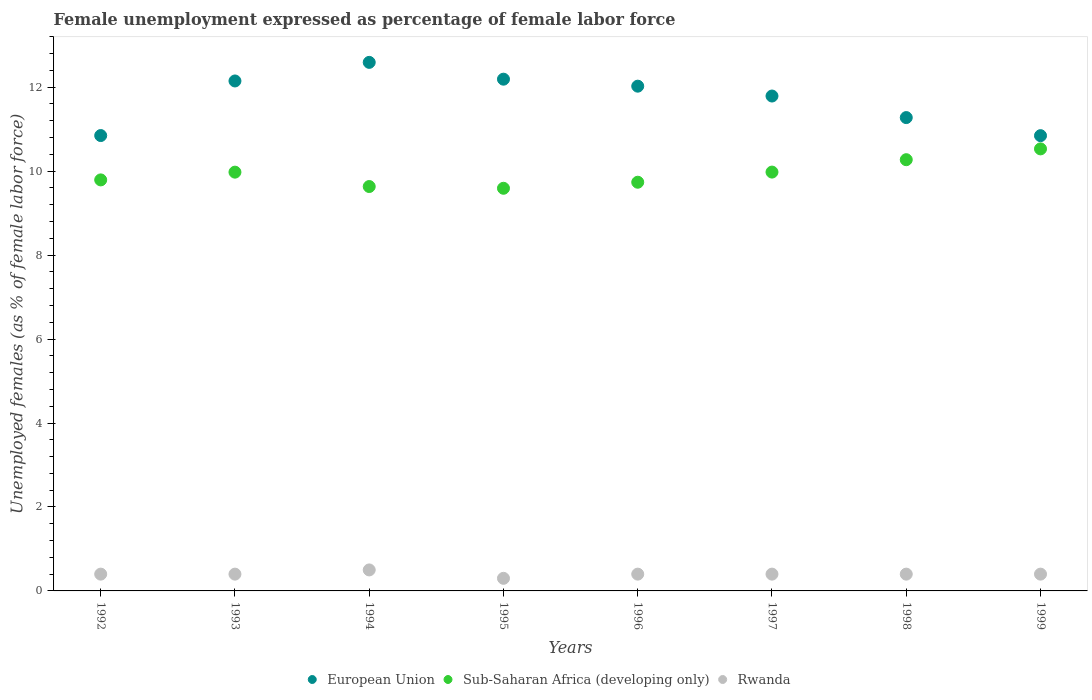What is the unemployment in females in in European Union in 1998?
Offer a terse response. 11.28. Across all years, what is the maximum unemployment in females in in Sub-Saharan Africa (developing only)?
Provide a short and direct response. 10.53. Across all years, what is the minimum unemployment in females in in European Union?
Make the answer very short. 10.84. In which year was the unemployment in females in in Rwanda maximum?
Provide a succinct answer. 1994. What is the total unemployment in females in in European Union in the graph?
Your answer should be compact. 93.71. What is the difference between the unemployment in females in in European Union in 1994 and that in 1995?
Provide a succinct answer. 0.4. What is the difference between the unemployment in females in in Rwanda in 1993 and the unemployment in females in in European Union in 1997?
Provide a succinct answer. -11.39. What is the average unemployment in females in in European Union per year?
Provide a succinct answer. 11.71. In the year 1998, what is the difference between the unemployment in females in in Sub-Saharan Africa (developing only) and unemployment in females in in European Union?
Offer a very short reply. -1. What is the ratio of the unemployment in females in in Rwanda in 1995 to that in 1998?
Ensure brevity in your answer.  0.75. Is the unemployment in females in in European Union in 1992 less than that in 1993?
Offer a terse response. Yes. What is the difference between the highest and the second highest unemployment in females in in Rwanda?
Make the answer very short. 0.1. What is the difference between the highest and the lowest unemployment in females in in Sub-Saharan Africa (developing only)?
Ensure brevity in your answer.  0.94. In how many years, is the unemployment in females in in European Union greater than the average unemployment in females in in European Union taken over all years?
Your response must be concise. 5. Is the sum of the unemployment in females in in European Union in 1992 and 1995 greater than the maximum unemployment in females in in Sub-Saharan Africa (developing only) across all years?
Ensure brevity in your answer.  Yes. Is it the case that in every year, the sum of the unemployment in females in in Rwanda and unemployment in females in in European Union  is greater than the unemployment in females in in Sub-Saharan Africa (developing only)?
Make the answer very short. Yes. Does the unemployment in females in in Rwanda monotonically increase over the years?
Make the answer very short. No. Is the unemployment in females in in Sub-Saharan Africa (developing only) strictly greater than the unemployment in females in in European Union over the years?
Offer a very short reply. No. Is the unemployment in females in in Sub-Saharan Africa (developing only) strictly less than the unemployment in females in in European Union over the years?
Ensure brevity in your answer.  Yes. Are the values on the major ticks of Y-axis written in scientific E-notation?
Offer a very short reply. No. Does the graph contain any zero values?
Your answer should be compact. No. How many legend labels are there?
Offer a terse response. 3. What is the title of the graph?
Offer a terse response. Female unemployment expressed as percentage of female labor force. Does "Sao Tome and Principe" appear as one of the legend labels in the graph?
Ensure brevity in your answer.  No. What is the label or title of the X-axis?
Provide a short and direct response. Years. What is the label or title of the Y-axis?
Your response must be concise. Unemployed females (as % of female labor force). What is the Unemployed females (as % of female labor force) in European Union in 1992?
Keep it short and to the point. 10.85. What is the Unemployed females (as % of female labor force) in Sub-Saharan Africa (developing only) in 1992?
Provide a short and direct response. 9.79. What is the Unemployed females (as % of female labor force) in Rwanda in 1992?
Offer a very short reply. 0.4. What is the Unemployed females (as % of female labor force) in European Union in 1993?
Provide a succinct answer. 12.15. What is the Unemployed females (as % of female labor force) of Sub-Saharan Africa (developing only) in 1993?
Ensure brevity in your answer.  9.98. What is the Unemployed females (as % of female labor force) of Rwanda in 1993?
Make the answer very short. 0.4. What is the Unemployed females (as % of female labor force) of European Union in 1994?
Your response must be concise. 12.59. What is the Unemployed females (as % of female labor force) in Sub-Saharan Africa (developing only) in 1994?
Offer a terse response. 9.63. What is the Unemployed females (as % of female labor force) of European Union in 1995?
Keep it short and to the point. 12.19. What is the Unemployed females (as % of female labor force) of Sub-Saharan Africa (developing only) in 1995?
Keep it short and to the point. 9.59. What is the Unemployed females (as % of female labor force) in Rwanda in 1995?
Ensure brevity in your answer.  0.3. What is the Unemployed females (as % of female labor force) of European Union in 1996?
Your answer should be very brief. 12.02. What is the Unemployed females (as % of female labor force) in Sub-Saharan Africa (developing only) in 1996?
Your response must be concise. 9.74. What is the Unemployed females (as % of female labor force) of Rwanda in 1996?
Make the answer very short. 0.4. What is the Unemployed females (as % of female labor force) of European Union in 1997?
Your answer should be very brief. 11.79. What is the Unemployed females (as % of female labor force) in Sub-Saharan Africa (developing only) in 1997?
Ensure brevity in your answer.  9.98. What is the Unemployed females (as % of female labor force) in Rwanda in 1997?
Make the answer very short. 0.4. What is the Unemployed females (as % of female labor force) in European Union in 1998?
Make the answer very short. 11.28. What is the Unemployed females (as % of female labor force) in Sub-Saharan Africa (developing only) in 1998?
Your response must be concise. 10.27. What is the Unemployed females (as % of female labor force) in Rwanda in 1998?
Your answer should be compact. 0.4. What is the Unemployed females (as % of female labor force) in European Union in 1999?
Offer a very short reply. 10.84. What is the Unemployed females (as % of female labor force) in Sub-Saharan Africa (developing only) in 1999?
Your answer should be compact. 10.53. What is the Unemployed females (as % of female labor force) of Rwanda in 1999?
Make the answer very short. 0.4. Across all years, what is the maximum Unemployed females (as % of female labor force) in European Union?
Keep it short and to the point. 12.59. Across all years, what is the maximum Unemployed females (as % of female labor force) in Sub-Saharan Africa (developing only)?
Your answer should be very brief. 10.53. Across all years, what is the minimum Unemployed females (as % of female labor force) of European Union?
Provide a succinct answer. 10.84. Across all years, what is the minimum Unemployed females (as % of female labor force) of Sub-Saharan Africa (developing only)?
Your response must be concise. 9.59. Across all years, what is the minimum Unemployed females (as % of female labor force) in Rwanda?
Offer a very short reply. 0.3. What is the total Unemployed females (as % of female labor force) of European Union in the graph?
Provide a short and direct response. 93.71. What is the total Unemployed females (as % of female labor force) in Sub-Saharan Africa (developing only) in the graph?
Keep it short and to the point. 79.51. What is the difference between the Unemployed females (as % of female labor force) in European Union in 1992 and that in 1993?
Provide a short and direct response. -1.3. What is the difference between the Unemployed females (as % of female labor force) of Sub-Saharan Africa (developing only) in 1992 and that in 1993?
Your answer should be compact. -0.18. What is the difference between the Unemployed females (as % of female labor force) in European Union in 1992 and that in 1994?
Your answer should be very brief. -1.74. What is the difference between the Unemployed females (as % of female labor force) in Sub-Saharan Africa (developing only) in 1992 and that in 1994?
Offer a terse response. 0.16. What is the difference between the Unemployed females (as % of female labor force) of Rwanda in 1992 and that in 1994?
Offer a terse response. -0.1. What is the difference between the Unemployed females (as % of female labor force) in European Union in 1992 and that in 1995?
Give a very brief answer. -1.34. What is the difference between the Unemployed females (as % of female labor force) of Sub-Saharan Africa (developing only) in 1992 and that in 1995?
Your answer should be very brief. 0.2. What is the difference between the Unemployed females (as % of female labor force) in European Union in 1992 and that in 1996?
Give a very brief answer. -1.18. What is the difference between the Unemployed females (as % of female labor force) in Sub-Saharan Africa (developing only) in 1992 and that in 1996?
Offer a very short reply. 0.06. What is the difference between the Unemployed females (as % of female labor force) of European Union in 1992 and that in 1997?
Keep it short and to the point. -0.94. What is the difference between the Unemployed females (as % of female labor force) of Sub-Saharan Africa (developing only) in 1992 and that in 1997?
Make the answer very short. -0.19. What is the difference between the Unemployed females (as % of female labor force) in European Union in 1992 and that in 1998?
Provide a succinct answer. -0.43. What is the difference between the Unemployed females (as % of female labor force) of Sub-Saharan Africa (developing only) in 1992 and that in 1998?
Ensure brevity in your answer.  -0.48. What is the difference between the Unemployed females (as % of female labor force) of European Union in 1992 and that in 1999?
Make the answer very short. 0. What is the difference between the Unemployed females (as % of female labor force) in Sub-Saharan Africa (developing only) in 1992 and that in 1999?
Offer a terse response. -0.74. What is the difference between the Unemployed females (as % of female labor force) in European Union in 1993 and that in 1994?
Provide a short and direct response. -0.44. What is the difference between the Unemployed females (as % of female labor force) of Sub-Saharan Africa (developing only) in 1993 and that in 1994?
Make the answer very short. 0.34. What is the difference between the Unemployed females (as % of female labor force) of European Union in 1993 and that in 1995?
Offer a terse response. -0.04. What is the difference between the Unemployed females (as % of female labor force) in Sub-Saharan Africa (developing only) in 1993 and that in 1995?
Offer a very short reply. 0.38. What is the difference between the Unemployed females (as % of female labor force) of Rwanda in 1993 and that in 1995?
Your response must be concise. 0.1. What is the difference between the Unemployed females (as % of female labor force) in European Union in 1993 and that in 1996?
Your answer should be compact. 0.12. What is the difference between the Unemployed females (as % of female labor force) of Sub-Saharan Africa (developing only) in 1993 and that in 1996?
Make the answer very short. 0.24. What is the difference between the Unemployed females (as % of female labor force) of European Union in 1993 and that in 1997?
Your answer should be very brief. 0.36. What is the difference between the Unemployed females (as % of female labor force) of Sub-Saharan Africa (developing only) in 1993 and that in 1997?
Give a very brief answer. -0. What is the difference between the Unemployed females (as % of female labor force) in Rwanda in 1993 and that in 1997?
Your response must be concise. 0. What is the difference between the Unemployed females (as % of female labor force) in European Union in 1993 and that in 1998?
Provide a succinct answer. 0.87. What is the difference between the Unemployed females (as % of female labor force) in Sub-Saharan Africa (developing only) in 1993 and that in 1998?
Provide a succinct answer. -0.3. What is the difference between the Unemployed females (as % of female labor force) in European Union in 1993 and that in 1999?
Provide a short and direct response. 1.3. What is the difference between the Unemployed females (as % of female labor force) in Sub-Saharan Africa (developing only) in 1993 and that in 1999?
Your response must be concise. -0.55. What is the difference between the Unemployed females (as % of female labor force) of European Union in 1994 and that in 1995?
Your answer should be very brief. 0.4. What is the difference between the Unemployed females (as % of female labor force) in Sub-Saharan Africa (developing only) in 1994 and that in 1995?
Keep it short and to the point. 0.04. What is the difference between the Unemployed females (as % of female labor force) of European Union in 1994 and that in 1996?
Your answer should be compact. 0.57. What is the difference between the Unemployed females (as % of female labor force) of Sub-Saharan Africa (developing only) in 1994 and that in 1996?
Offer a terse response. -0.1. What is the difference between the Unemployed females (as % of female labor force) in European Union in 1994 and that in 1997?
Make the answer very short. 0.8. What is the difference between the Unemployed females (as % of female labor force) of Sub-Saharan Africa (developing only) in 1994 and that in 1997?
Offer a very short reply. -0.34. What is the difference between the Unemployed females (as % of female labor force) in Rwanda in 1994 and that in 1997?
Provide a short and direct response. 0.1. What is the difference between the Unemployed females (as % of female labor force) of European Union in 1994 and that in 1998?
Offer a very short reply. 1.32. What is the difference between the Unemployed females (as % of female labor force) of Sub-Saharan Africa (developing only) in 1994 and that in 1998?
Keep it short and to the point. -0.64. What is the difference between the Unemployed females (as % of female labor force) in European Union in 1994 and that in 1999?
Offer a very short reply. 1.75. What is the difference between the Unemployed females (as % of female labor force) in Sub-Saharan Africa (developing only) in 1994 and that in 1999?
Your response must be concise. -0.9. What is the difference between the Unemployed females (as % of female labor force) of European Union in 1995 and that in 1996?
Your answer should be compact. 0.17. What is the difference between the Unemployed females (as % of female labor force) of Sub-Saharan Africa (developing only) in 1995 and that in 1996?
Keep it short and to the point. -0.14. What is the difference between the Unemployed females (as % of female labor force) in European Union in 1995 and that in 1997?
Your answer should be very brief. 0.4. What is the difference between the Unemployed females (as % of female labor force) in Sub-Saharan Africa (developing only) in 1995 and that in 1997?
Your response must be concise. -0.39. What is the difference between the Unemployed females (as % of female labor force) in European Union in 1995 and that in 1998?
Your answer should be very brief. 0.91. What is the difference between the Unemployed females (as % of female labor force) in Sub-Saharan Africa (developing only) in 1995 and that in 1998?
Keep it short and to the point. -0.68. What is the difference between the Unemployed females (as % of female labor force) of Rwanda in 1995 and that in 1998?
Offer a terse response. -0.1. What is the difference between the Unemployed females (as % of female labor force) in European Union in 1995 and that in 1999?
Offer a very short reply. 1.35. What is the difference between the Unemployed females (as % of female labor force) in Sub-Saharan Africa (developing only) in 1995 and that in 1999?
Ensure brevity in your answer.  -0.94. What is the difference between the Unemployed females (as % of female labor force) of Rwanda in 1995 and that in 1999?
Keep it short and to the point. -0.1. What is the difference between the Unemployed females (as % of female labor force) of European Union in 1996 and that in 1997?
Your response must be concise. 0.23. What is the difference between the Unemployed females (as % of female labor force) of Sub-Saharan Africa (developing only) in 1996 and that in 1997?
Ensure brevity in your answer.  -0.24. What is the difference between the Unemployed females (as % of female labor force) in Rwanda in 1996 and that in 1997?
Provide a succinct answer. 0. What is the difference between the Unemployed females (as % of female labor force) of European Union in 1996 and that in 1998?
Offer a terse response. 0.75. What is the difference between the Unemployed females (as % of female labor force) of Sub-Saharan Africa (developing only) in 1996 and that in 1998?
Make the answer very short. -0.54. What is the difference between the Unemployed females (as % of female labor force) of Rwanda in 1996 and that in 1998?
Your answer should be very brief. 0. What is the difference between the Unemployed females (as % of female labor force) of European Union in 1996 and that in 1999?
Offer a very short reply. 1.18. What is the difference between the Unemployed females (as % of female labor force) of Sub-Saharan Africa (developing only) in 1996 and that in 1999?
Offer a terse response. -0.79. What is the difference between the Unemployed females (as % of female labor force) in European Union in 1997 and that in 1998?
Give a very brief answer. 0.51. What is the difference between the Unemployed females (as % of female labor force) of Sub-Saharan Africa (developing only) in 1997 and that in 1998?
Keep it short and to the point. -0.3. What is the difference between the Unemployed females (as % of female labor force) in Rwanda in 1997 and that in 1998?
Keep it short and to the point. 0. What is the difference between the Unemployed females (as % of female labor force) in European Union in 1997 and that in 1999?
Offer a terse response. 0.94. What is the difference between the Unemployed females (as % of female labor force) in Sub-Saharan Africa (developing only) in 1997 and that in 1999?
Keep it short and to the point. -0.55. What is the difference between the Unemployed females (as % of female labor force) in Rwanda in 1997 and that in 1999?
Offer a terse response. 0. What is the difference between the Unemployed females (as % of female labor force) in European Union in 1998 and that in 1999?
Give a very brief answer. 0.43. What is the difference between the Unemployed females (as % of female labor force) of Sub-Saharan Africa (developing only) in 1998 and that in 1999?
Offer a terse response. -0.26. What is the difference between the Unemployed females (as % of female labor force) in Rwanda in 1998 and that in 1999?
Provide a succinct answer. 0. What is the difference between the Unemployed females (as % of female labor force) of European Union in 1992 and the Unemployed females (as % of female labor force) of Sub-Saharan Africa (developing only) in 1993?
Offer a terse response. 0.87. What is the difference between the Unemployed females (as % of female labor force) in European Union in 1992 and the Unemployed females (as % of female labor force) in Rwanda in 1993?
Your response must be concise. 10.45. What is the difference between the Unemployed females (as % of female labor force) in Sub-Saharan Africa (developing only) in 1992 and the Unemployed females (as % of female labor force) in Rwanda in 1993?
Keep it short and to the point. 9.39. What is the difference between the Unemployed females (as % of female labor force) of European Union in 1992 and the Unemployed females (as % of female labor force) of Sub-Saharan Africa (developing only) in 1994?
Provide a succinct answer. 1.21. What is the difference between the Unemployed females (as % of female labor force) of European Union in 1992 and the Unemployed females (as % of female labor force) of Rwanda in 1994?
Your response must be concise. 10.35. What is the difference between the Unemployed females (as % of female labor force) of Sub-Saharan Africa (developing only) in 1992 and the Unemployed females (as % of female labor force) of Rwanda in 1994?
Offer a terse response. 9.29. What is the difference between the Unemployed females (as % of female labor force) in European Union in 1992 and the Unemployed females (as % of female labor force) in Sub-Saharan Africa (developing only) in 1995?
Offer a very short reply. 1.26. What is the difference between the Unemployed females (as % of female labor force) in European Union in 1992 and the Unemployed females (as % of female labor force) in Rwanda in 1995?
Your response must be concise. 10.55. What is the difference between the Unemployed females (as % of female labor force) in Sub-Saharan Africa (developing only) in 1992 and the Unemployed females (as % of female labor force) in Rwanda in 1995?
Provide a short and direct response. 9.49. What is the difference between the Unemployed females (as % of female labor force) of European Union in 1992 and the Unemployed females (as % of female labor force) of Sub-Saharan Africa (developing only) in 1996?
Your answer should be compact. 1.11. What is the difference between the Unemployed females (as % of female labor force) of European Union in 1992 and the Unemployed females (as % of female labor force) of Rwanda in 1996?
Give a very brief answer. 10.45. What is the difference between the Unemployed females (as % of female labor force) in Sub-Saharan Africa (developing only) in 1992 and the Unemployed females (as % of female labor force) in Rwanda in 1996?
Your response must be concise. 9.39. What is the difference between the Unemployed females (as % of female labor force) in European Union in 1992 and the Unemployed females (as % of female labor force) in Sub-Saharan Africa (developing only) in 1997?
Provide a short and direct response. 0.87. What is the difference between the Unemployed females (as % of female labor force) in European Union in 1992 and the Unemployed females (as % of female labor force) in Rwanda in 1997?
Make the answer very short. 10.45. What is the difference between the Unemployed females (as % of female labor force) in Sub-Saharan Africa (developing only) in 1992 and the Unemployed females (as % of female labor force) in Rwanda in 1997?
Offer a very short reply. 9.39. What is the difference between the Unemployed females (as % of female labor force) of European Union in 1992 and the Unemployed females (as % of female labor force) of Sub-Saharan Africa (developing only) in 1998?
Keep it short and to the point. 0.57. What is the difference between the Unemployed females (as % of female labor force) in European Union in 1992 and the Unemployed females (as % of female labor force) in Rwanda in 1998?
Your response must be concise. 10.45. What is the difference between the Unemployed females (as % of female labor force) of Sub-Saharan Africa (developing only) in 1992 and the Unemployed females (as % of female labor force) of Rwanda in 1998?
Keep it short and to the point. 9.39. What is the difference between the Unemployed females (as % of female labor force) of European Union in 1992 and the Unemployed females (as % of female labor force) of Sub-Saharan Africa (developing only) in 1999?
Keep it short and to the point. 0.32. What is the difference between the Unemployed females (as % of female labor force) of European Union in 1992 and the Unemployed females (as % of female labor force) of Rwanda in 1999?
Offer a very short reply. 10.45. What is the difference between the Unemployed females (as % of female labor force) of Sub-Saharan Africa (developing only) in 1992 and the Unemployed females (as % of female labor force) of Rwanda in 1999?
Offer a terse response. 9.39. What is the difference between the Unemployed females (as % of female labor force) in European Union in 1993 and the Unemployed females (as % of female labor force) in Sub-Saharan Africa (developing only) in 1994?
Your answer should be very brief. 2.51. What is the difference between the Unemployed females (as % of female labor force) of European Union in 1993 and the Unemployed females (as % of female labor force) of Rwanda in 1994?
Your response must be concise. 11.65. What is the difference between the Unemployed females (as % of female labor force) in Sub-Saharan Africa (developing only) in 1993 and the Unemployed females (as % of female labor force) in Rwanda in 1994?
Ensure brevity in your answer.  9.48. What is the difference between the Unemployed females (as % of female labor force) of European Union in 1993 and the Unemployed females (as % of female labor force) of Sub-Saharan Africa (developing only) in 1995?
Your response must be concise. 2.56. What is the difference between the Unemployed females (as % of female labor force) in European Union in 1993 and the Unemployed females (as % of female labor force) in Rwanda in 1995?
Ensure brevity in your answer.  11.85. What is the difference between the Unemployed females (as % of female labor force) in Sub-Saharan Africa (developing only) in 1993 and the Unemployed females (as % of female labor force) in Rwanda in 1995?
Ensure brevity in your answer.  9.68. What is the difference between the Unemployed females (as % of female labor force) of European Union in 1993 and the Unemployed females (as % of female labor force) of Sub-Saharan Africa (developing only) in 1996?
Provide a short and direct response. 2.41. What is the difference between the Unemployed females (as % of female labor force) in European Union in 1993 and the Unemployed females (as % of female labor force) in Rwanda in 1996?
Give a very brief answer. 11.75. What is the difference between the Unemployed females (as % of female labor force) in Sub-Saharan Africa (developing only) in 1993 and the Unemployed females (as % of female labor force) in Rwanda in 1996?
Provide a succinct answer. 9.58. What is the difference between the Unemployed females (as % of female labor force) in European Union in 1993 and the Unemployed females (as % of female labor force) in Sub-Saharan Africa (developing only) in 1997?
Offer a very short reply. 2.17. What is the difference between the Unemployed females (as % of female labor force) of European Union in 1993 and the Unemployed females (as % of female labor force) of Rwanda in 1997?
Your answer should be very brief. 11.75. What is the difference between the Unemployed females (as % of female labor force) in Sub-Saharan Africa (developing only) in 1993 and the Unemployed females (as % of female labor force) in Rwanda in 1997?
Offer a terse response. 9.58. What is the difference between the Unemployed females (as % of female labor force) of European Union in 1993 and the Unemployed females (as % of female labor force) of Sub-Saharan Africa (developing only) in 1998?
Give a very brief answer. 1.88. What is the difference between the Unemployed females (as % of female labor force) in European Union in 1993 and the Unemployed females (as % of female labor force) in Rwanda in 1998?
Ensure brevity in your answer.  11.75. What is the difference between the Unemployed females (as % of female labor force) of Sub-Saharan Africa (developing only) in 1993 and the Unemployed females (as % of female labor force) of Rwanda in 1998?
Keep it short and to the point. 9.58. What is the difference between the Unemployed females (as % of female labor force) in European Union in 1993 and the Unemployed females (as % of female labor force) in Sub-Saharan Africa (developing only) in 1999?
Offer a terse response. 1.62. What is the difference between the Unemployed females (as % of female labor force) of European Union in 1993 and the Unemployed females (as % of female labor force) of Rwanda in 1999?
Make the answer very short. 11.75. What is the difference between the Unemployed females (as % of female labor force) in Sub-Saharan Africa (developing only) in 1993 and the Unemployed females (as % of female labor force) in Rwanda in 1999?
Ensure brevity in your answer.  9.58. What is the difference between the Unemployed females (as % of female labor force) of European Union in 1994 and the Unemployed females (as % of female labor force) of Sub-Saharan Africa (developing only) in 1995?
Your answer should be very brief. 3. What is the difference between the Unemployed females (as % of female labor force) in European Union in 1994 and the Unemployed females (as % of female labor force) in Rwanda in 1995?
Your answer should be very brief. 12.29. What is the difference between the Unemployed females (as % of female labor force) of Sub-Saharan Africa (developing only) in 1994 and the Unemployed females (as % of female labor force) of Rwanda in 1995?
Offer a terse response. 9.33. What is the difference between the Unemployed females (as % of female labor force) in European Union in 1994 and the Unemployed females (as % of female labor force) in Sub-Saharan Africa (developing only) in 1996?
Make the answer very short. 2.86. What is the difference between the Unemployed females (as % of female labor force) of European Union in 1994 and the Unemployed females (as % of female labor force) of Rwanda in 1996?
Your answer should be compact. 12.19. What is the difference between the Unemployed females (as % of female labor force) in Sub-Saharan Africa (developing only) in 1994 and the Unemployed females (as % of female labor force) in Rwanda in 1996?
Ensure brevity in your answer.  9.23. What is the difference between the Unemployed females (as % of female labor force) of European Union in 1994 and the Unemployed females (as % of female labor force) of Sub-Saharan Africa (developing only) in 1997?
Provide a succinct answer. 2.61. What is the difference between the Unemployed females (as % of female labor force) of European Union in 1994 and the Unemployed females (as % of female labor force) of Rwanda in 1997?
Keep it short and to the point. 12.19. What is the difference between the Unemployed females (as % of female labor force) in Sub-Saharan Africa (developing only) in 1994 and the Unemployed females (as % of female labor force) in Rwanda in 1997?
Provide a succinct answer. 9.23. What is the difference between the Unemployed females (as % of female labor force) in European Union in 1994 and the Unemployed females (as % of female labor force) in Sub-Saharan Africa (developing only) in 1998?
Make the answer very short. 2.32. What is the difference between the Unemployed females (as % of female labor force) of European Union in 1994 and the Unemployed females (as % of female labor force) of Rwanda in 1998?
Ensure brevity in your answer.  12.19. What is the difference between the Unemployed females (as % of female labor force) in Sub-Saharan Africa (developing only) in 1994 and the Unemployed females (as % of female labor force) in Rwanda in 1998?
Offer a very short reply. 9.23. What is the difference between the Unemployed females (as % of female labor force) in European Union in 1994 and the Unemployed females (as % of female labor force) in Sub-Saharan Africa (developing only) in 1999?
Make the answer very short. 2.06. What is the difference between the Unemployed females (as % of female labor force) in European Union in 1994 and the Unemployed females (as % of female labor force) in Rwanda in 1999?
Offer a terse response. 12.19. What is the difference between the Unemployed females (as % of female labor force) in Sub-Saharan Africa (developing only) in 1994 and the Unemployed females (as % of female labor force) in Rwanda in 1999?
Ensure brevity in your answer.  9.23. What is the difference between the Unemployed females (as % of female labor force) in European Union in 1995 and the Unemployed females (as % of female labor force) in Sub-Saharan Africa (developing only) in 1996?
Offer a very short reply. 2.45. What is the difference between the Unemployed females (as % of female labor force) in European Union in 1995 and the Unemployed females (as % of female labor force) in Rwanda in 1996?
Your answer should be compact. 11.79. What is the difference between the Unemployed females (as % of female labor force) in Sub-Saharan Africa (developing only) in 1995 and the Unemployed females (as % of female labor force) in Rwanda in 1996?
Your answer should be very brief. 9.19. What is the difference between the Unemployed females (as % of female labor force) in European Union in 1995 and the Unemployed females (as % of female labor force) in Sub-Saharan Africa (developing only) in 1997?
Keep it short and to the point. 2.21. What is the difference between the Unemployed females (as % of female labor force) in European Union in 1995 and the Unemployed females (as % of female labor force) in Rwanda in 1997?
Your answer should be compact. 11.79. What is the difference between the Unemployed females (as % of female labor force) in Sub-Saharan Africa (developing only) in 1995 and the Unemployed females (as % of female labor force) in Rwanda in 1997?
Keep it short and to the point. 9.19. What is the difference between the Unemployed females (as % of female labor force) in European Union in 1995 and the Unemployed females (as % of female labor force) in Sub-Saharan Africa (developing only) in 1998?
Make the answer very short. 1.92. What is the difference between the Unemployed females (as % of female labor force) of European Union in 1995 and the Unemployed females (as % of female labor force) of Rwanda in 1998?
Your response must be concise. 11.79. What is the difference between the Unemployed females (as % of female labor force) in Sub-Saharan Africa (developing only) in 1995 and the Unemployed females (as % of female labor force) in Rwanda in 1998?
Make the answer very short. 9.19. What is the difference between the Unemployed females (as % of female labor force) of European Union in 1995 and the Unemployed females (as % of female labor force) of Sub-Saharan Africa (developing only) in 1999?
Provide a short and direct response. 1.66. What is the difference between the Unemployed females (as % of female labor force) in European Union in 1995 and the Unemployed females (as % of female labor force) in Rwanda in 1999?
Give a very brief answer. 11.79. What is the difference between the Unemployed females (as % of female labor force) of Sub-Saharan Africa (developing only) in 1995 and the Unemployed females (as % of female labor force) of Rwanda in 1999?
Keep it short and to the point. 9.19. What is the difference between the Unemployed females (as % of female labor force) of European Union in 1996 and the Unemployed females (as % of female labor force) of Sub-Saharan Africa (developing only) in 1997?
Keep it short and to the point. 2.05. What is the difference between the Unemployed females (as % of female labor force) in European Union in 1996 and the Unemployed females (as % of female labor force) in Rwanda in 1997?
Your answer should be compact. 11.62. What is the difference between the Unemployed females (as % of female labor force) of Sub-Saharan Africa (developing only) in 1996 and the Unemployed females (as % of female labor force) of Rwanda in 1997?
Provide a succinct answer. 9.34. What is the difference between the Unemployed females (as % of female labor force) in European Union in 1996 and the Unemployed females (as % of female labor force) in Sub-Saharan Africa (developing only) in 1998?
Provide a succinct answer. 1.75. What is the difference between the Unemployed females (as % of female labor force) of European Union in 1996 and the Unemployed females (as % of female labor force) of Rwanda in 1998?
Provide a short and direct response. 11.62. What is the difference between the Unemployed females (as % of female labor force) in Sub-Saharan Africa (developing only) in 1996 and the Unemployed females (as % of female labor force) in Rwanda in 1998?
Ensure brevity in your answer.  9.34. What is the difference between the Unemployed females (as % of female labor force) in European Union in 1996 and the Unemployed females (as % of female labor force) in Sub-Saharan Africa (developing only) in 1999?
Ensure brevity in your answer.  1.49. What is the difference between the Unemployed females (as % of female labor force) in European Union in 1996 and the Unemployed females (as % of female labor force) in Rwanda in 1999?
Make the answer very short. 11.62. What is the difference between the Unemployed females (as % of female labor force) of Sub-Saharan Africa (developing only) in 1996 and the Unemployed females (as % of female labor force) of Rwanda in 1999?
Make the answer very short. 9.34. What is the difference between the Unemployed females (as % of female labor force) in European Union in 1997 and the Unemployed females (as % of female labor force) in Sub-Saharan Africa (developing only) in 1998?
Make the answer very short. 1.52. What is the difference between the Unemployed females (as % of female labor force) of European Union in 1997 and the Unemployed females (as % of female labor force) of Rwanda in 1998?
Your answer should be compact. 11.39. What is the difference between the Unemployed females (as % of female labor force) in Sub-Saharan Africa (developing only) in 1997 and the Unemployed females (as % of female labor force) in Rwanda in 1998?
Your answer should be very brief. 9.58. What is the difference between the Unemployed females (as % of female labor force) in European Union in 1997 and the Unemployed females (as % of female labor force) in Sub-Saharan Africa (developing only) in 1999?
Give a very brief answer. 1.26. What is the difference between the Unemployed females (as % of female labor force) of European Union in 1997 and the Unemployed females (as % of female labor force) of Rwanda in 1999?
Your answer should be compact. 11.39. What is the difference between the Unemployed females (as % of female labor force) in Sub-Saharan Africa (developing only) in 1997 and the Unemployed females (as % of female labor force) in Rwanda in 1999?
Offer a very short reply. 9.58. What is the difference between the Unemployed females (as % of female labor force) of European Union in 1998 and the Unemployed females (as % of female labor force) of Sub-Saharan Africa (developing only) in 1999?
Provide a succinct answer. 0.75. What is the difference between the Unemployed females (as % of female labor force) of European Union in 1998 and the Unemployed females (as % of female labor force) of Rwanda in 1999?
Keep it short and to the point. 10.88. What is the difference between the Unemployed females (as % of female labor force) in Sub-Saharan Africa (developing only) in 1998 and the Unemployed females (as % of female labor force) in Rwanda in 1999?
Give a very brief answer. 9.87. What is the average Unemployed females (as % of female labor force) in European Union per year?
Make the answer very short. 11.71. What is the average Unemployed females (as % of female labor force) of Sub-Saharan Africa (developing only) per year?
Offer a very short reply. 9.94. In the year 1992, what is the difference between the Unemployed females (as % of female labor force) of European Union and Unemployed females (as % of female labor force) of Sub-Saharan Africa (developing only)?
Keep it short and to the point. 1.06. In the year 1992, what is the difference between the Unemployed females (as % of female labor force) of European Union and Unemployed females (as % of female labor force) of Rwanda?
Give a very brief answer. 10.45. In the year 1992, what is the difference between the Unemployed females (as % of female labor force) of Sub-Saharan Africa (developing only) and Unemployed females (as % of female labor force) of Rwanda?
Keep it short and to the point. 9.39. In the year 1993, what is the difference between the Unemployed females (as % of female labor force) in European Union and Unemployed females (as % of female labor force) in Sub-Saharan Africa (developing only)?
Make the answer very short. 2.17. In the year 1993, what is the difference between the Unemployed females (as % of female labor force) of European Union and Unemployed females (as % of female labor force) of Rwanda?
Provide a short and direct response. 11.75. In the year 1993, what is the difference between the Unemployed females (as % of female labor force) of Sub-Saharan Africa (developing only) and Unemployed females (as % of female labor force) of Rwanda?
Provide a short and direct response. 9.58. In the year 1994, what is the difference between the Unemployed females (as % of female labor force) of European Union and Unemployed females (as % of female labor force) of Sub-Saharan Africa (developing only)?
Your answer should be compact. 2.96. In the year 1994, what is the difference between the Unemployed females (as % of female labor force) of European Union and Unemployed females (as % of female labor force) of Rwanda?
Your response must be concise. 12.09. In the year 1994, what is the difference between the Unemployed females (as % of female labor force) in Sub-Saharan Africa (developing only) and Unemployed females (as % of female labor force) in Rwanda?
Your answer should be compact. 9.13. In the year 1995, what is the difference between the Unemployed females (as % of female labor force) of European Union and Unemployed females (as % of female labor force) of Sub-Saharan Africa (developing only)?
Offer a terse response. 2.6. In the year 1995, what is the difference between the Unemployed females (as % of female labor force) in European Union and Unemployed females (as % of female labor force) in Rwanda?
Offer a terse response. 11.89. In the year 1995, what is the difference between the Unemployed females (as % of female labor force) in Sub-Saharan Africa (developing only) and Unemployed females (as % of female labor force) in Rwanda?
Your response must be concise. 9.29. In the year 1996, what is the difference between the Unemployed females (as % of female labor force) in European Union and Unemployed females (as % of female labor force) in Sub-Saharan Africa (developing only)?
Provide a short and direct response. 2.29. In the year 1996, what is the difference between the Unemployed females (as % of female labor force) in European Union and Unemployed females (as % of female labor force) in Rwanda?
Make the answer very short. 11.62. In the year 1996, what is the difference between the Unemployed females (as % of female labor force) of Sub-Saharan Africa (developing only) and Unemployed females (as % of female labor force) of Rwanda?
Offer a terse response. 9.34. In the year 1997, what is the difference between the Unemployed females (as % of female labor force) in European Union and Unemployed females (as % of female labor force) in Sub-Saharan Africa (developing only)?
Provide a succinct answer. 1.81. In the year 1997, what is the difference between the Unemployed females (as % of female labor force) of European Union and Unemployed females (as % of female labor force) of Rwanda?
Your response must be concise. 11.39. In the year 1997, what is the difference between the Unemployed females (as % of female labor force) of Sub-Saharan Africa (developing only) and Unemployed females (as % of female labor force) of Rwanda?
Make the answer very short. 9.58. In the year 1998, what is the difference between the Unemployed females (as % of female labor force) of European Union and Unemployed females (as % of female labor force) of Sub-Saharan Africa (developing only)?
Provide a succinct answer. 1. In the year 1998, what is the difference between the Unemployed females (as % of female labor force) in European Union and Unemployed females (as % of female labor force) in Rwanda?
Ensure brevity in your answer.  10.88. In the year 1998, what is the difference between the Unemployed females (as % of female labor force) of Sub-Saharan Africa (developing only) and Unemployed females (as % of female labor force) of Rwanda?
Offer a very short reply. 9.87. In the year 1999, what is the difference between the Unemployed females (as % of female labor force) in European Union and Unemployed females (as % of female labor force) in Sub-Saharan Africa (developing only)?
Provide a short and direct response. 0.31. In the year 1999, what is the difference between the Unemployed females (as % of female labor force) in European Union and Unemployed females (as % of female labor force) in Rwanda?
Ensure brevity in your answer.  10.44. In the year 1999, what is the difference between the Unemployed females (as % of female labor force) in Sub-Saharan Africa (developing only) and Unemployed females (as % of female labor force) in Rwanda?
Ensure brevity in your answer.  10.13. What is the ratio of the Unemployed females (as % of female labor force) in European Union in 1992 to that in 1993?
Make the answer very short. 0.89. What is the ratio of the Unemployed females (as % of female labor force) in Sub-Saharan Africa (developing only) in 1992 to that in 1993?
Provide a short and direct response. 0.98. What is the ratio of the Unemployed females (as % of female labor force) in Rwanda in 1992 to that in 1993?
Your answer should be compact. 1. What is the ratio of the Unemployed females (as % of female labor force) of European Union in 1992 to that in 1994?
Provide a succinct answer. 0.86. What is the ratio of the Unemployed females (as % of female labor force) of Sub-Saharan Africa (developing only) in 1992 to that in 1994?
Your answer should be very brief. 1.02. What is the ratio of the Unemployed females (as % of female labor force) in European Union in 1992 to that in 1995?
Provide a succinct answer. 0.89. What is the ratio of the Unemployed females (as % of female labor force) of Sub-Saharan Africa (developing only) in 1992 to that in 1995?
Your answer should be compact. 1.02. What is the ratio of the Unemployed females (as % of female labor force) of European Union in 1992 to that in 1996?
Give a very brief answer. 0.9. What is the ratio of the Unemployed females (as % of female labor force) in European Union in 1992 to that in 1997?
Your response must be concise. 0.92. What is the ratio of the Unemployed females (as % of female labor force) in Sub-Saharan Africa (developing only) in 1992 to that in 1997?
Give a very brief answer. 0.98. What is the ratio of the Unemployed females (as % of female labor force) in Sub-Saharan Africa (developing only) in 1992 to that in 1998?
Your response must be concise. 0.95. What is the ratio of the Unemployed females (as % of female labor force) in Rwanda in 1992 to that in 1998?
Make the answer very short. 1. What is the ratio of the Unemployed females (as % of female labor force) in European Union in 1992 to that in 1999?
Provide a succinct answer. 1. What is the ratio of the Unemployed females (as % of female labor force) in Sub-Saharan Africa (developing only) in 1992 to that in 1999?
Ensure brevity in your answer.  0.93. What is the ratio of the Unemployed females (as % of female labor force) of Rwanda in 1992 to that in 1999?
Your response must be concise. 1. What is the ratio of the Unemployed females (as % of female labor force) of European Union in 1993 to that in 1994?
Offer a terse response. 0.96. What is the ratio of the Unemployed females (as % of female labor force) in Sub-Saharan Africa (developing only) in 1993 to that in 1994?
Offer a terse response. 1.04. What is the ratio of the Unemployed females (as % of female labor force) of Rwanda in 1993 to that in 1994?
Offer a terse response. 0.8. What is the ratio of the Unemployed females (as % of female labor force) of European Union in 1993 to that in 1995?
Provide a short and direct response. 1. What is the ratio of the Unemployed females (as % of female labor force) of European Union in 1993 to that in 1996?
Your answer should be compact. 1.01. What is the ratio of the Unemployed females (as % of female labor force) of Sub-Saharan Africa (developing only) in 1993 to that in 1996?
Keep it short and to the point. 1.02. What is the ratio of the Unemployed females (as % of female labor force) of Rwanda in 1993 to that in 1996?
Give a very brief answer. 1. What is the ratio of the Unemployed females (as % of female labor force) of European Union in 1993 to that in 1997?
Your answer should be compact. 1.03. What is the ratio of the Unemployed females (as % of female labor force) of Sub-Saharan Africa (developing only) in 1993 to that in 1997?
Keep it short and to the point. 1. What is the ratio of the Unemployed females (as % of female labor force) in European Union in 1993 to that in 1998?
Give a very brief answer. 1.08. What is the ratio of the Unemployed females (as % of female labor force) of Sub-Saharan Africa (developing only) in 1993 to that in 1998?
Ensure brevity in your answer.  0.97. What is the ratio of the Unemployed females (as % of female labor force) in Rwanda in 1993 to that in 1998?
Make the answer very short. 1. What is the ratio of the Unemployed females (as % of female labor force) in European Union in 1993 to that in 1999?
Offer a very short reply. 1.12. What is the ratio of the Unemployed females (as % of female labor force) of European Union in 1994 to that in 1995?
Offer a very short reply. 1.03. What is the ratio of the Unemployed females (as % of female labor force) in Sub-Saharan Africa (developing only) in 1994 to that in 1995?
Your answer should be very brief. 1. What is the ratio of the Unemployed females (as % of female labor force) in European Union in 1994 to that in 1996?
Provide a short and direct response. 1.05. What is the ratio of the Unemployed females (as % of female labor force) of Sub-Saharan Africa (developing only) in 1994 to that in 1996?
Give a very brief answer. 0.99. What is the ratio of the Unemployed females (as % of female labor force) in Rwanda in 1994 to that in 1996?
Your response must be concise. 1.25. What is the ratio of the Unemployed females (as % of female labor force) of European Union in 1994 to that in 1997?
Provide a short and direct response. 1.07. What is the ratio of the Unemployed females (as % of female labor force) in Sub-Saharan Africa (developing only) in 1994 to that in 1997?
Ensure brevity in your answer.  0.97. What is the ratio of the Unemployed females (as % of female labor force) in European Union in 1994 to that in 1998?
Your response must be concise. 1.12. What is the ratio of the Unemployed females (as % of female labor force) in Sub-Saharan Africa (developing only) in 1994 to that in 1998?
Make the answer very short. 0.94. What is the ratio of the Unemployed females (as % of female labor force) in Rwanda in 1994 to that in 1998?
Offer a very short reply. 1.25. What is the ratio of the Unemployed females (as % of female labor force) in European Union in 1994 to that in 1999?
Ensure brevity in your answer.  1.16. What is the ratio of the Unemployed females (as % of female labor force) of Sub-Saharan Africa (developing only) in 1994 to that in 1999?
Provide a succinct answer. 0.91. What is the ratio of the Unemployed females (as % of female labor force) of Rwanda in 1994 to that in 1999?
Make the answer very short. 1.25. What is the ratio of the Unemployed females (as % of female labor force) of European Union in 1995 to that in 1996?
Make the answer very short. 1.01. What is the ratio of the Unemployed females (as % of female labor force) in Sub-Saharan Africa (developing only) in 1995 to that in 1996?
Provide a succinct answer. 0.99. What is the ratio of the Unemployed females (as % of female labor force) of European Union in 1995 to that in 1997?
Your answer should be very brief. 1.03. What is the ratio of the Unemployed females (as % of female labor force) of Sub-Saharan Africa (developing only) in 1995 to that in 1997?
Provide a succinct answer. 0.96. What is the ratio of the Unemployed females (as % of female labor force) of Rwanda in 1995 to that in 1997?
Offer a very short reply. 0.75. What is the ratio of the Unemployed females (as % of female labor force) of European Union in 1995 to that in 1998?
Your response must be concise. 1.08. What is the ratio of the Unemployed females (as % of female labor force) of Sub-Saharan Africa (developing only) in 1995 to that in 1998?
Keep it short and to the point. 0.93. What is the ratio of the Unemployed females (as % of female labor force) of Rwanda in 1995 to that in 1998?
Your answer should be compact. 0.75. What is the ratio of the Unemployed females (as % of female labor force) of European Union in 1995 to that in 1999?
Give a very brief answer. 1.12. What is the ratio of the Unemployed females (as % of female labor force) in Sub-Saharan Africa (developing only) in 1995 to that in 1999?
Offer a terse response. 0.91. What is the ratio of the Unemployed females (as % of female labor force) of Rwanda in 1995 to that in 1999?
Provide a succinct answer. 0.75. What is the ratio of the Unemployed females (as % of female labor force) of European Union in 1996 to that in 1997?
Your response must be concise. 1.02. What is the ratio of the Unemployed females (as % of female labor force) in Sub-Saharan Africa (developing only) in 1996 to that in 1997?
Offer a terse response. 0.98. What is the ratio of the Unemployed females (as % of female labor force) of European Union in 1996 to that in 1998?
Make the answer very short. 1.07. What is the ratio of the Unemployed females (as % of female labor force) of Sub-Saharan Africa (developing only) in 1996 to that in 1998?
Your answer should be compact. 0.95. What is the ratio of the Unemployed females (as % of female labor force) in Rwanda in 1996 to that in 1998?
Your answer should be compact. 1. What is the ratio of the Unemployed females (as % of female labor force) of European Union in 1996 to that in 1999?
Give a very brief answer. 1.11. What is the ratio of the Unemployed females (as % of female labor force) in Sub-Saharan Africa (developing only) in 1996 to that in 1999?
Your answer should be compact. 0.92. What is the ratio of the Unemployed females (as % of female labor force) in European Union in 1997 to that in 1998?
Ensure brevity in your answer.  1.05. What is the ratio of the Unemployed females (as % of female labor force) in Sub-Saharan Africa (developing only) in 1997 to that in 1998?
Your answer should be very brief. 0.97. What is the ratio of the Unemployed females (as % of female labor force) in Rwanda in 1997 to that in 1998?
Give a very brief answer. 1. What is the ratio of the Unemployed females (as % of female labor force) in European Union in 1997 to that in 1999?
Your answer should be very brief. 1.09. What is the ratio of the Unemployed females (as % of female labor force) of Sub-Saharan Africa (developing only) in 1997 to that in 1999?
Make the answer very short. 0.95. What is the ratio of the Unemployed females (as % of female labor force) in Rwanda in 1997 to that in 1999?
Offer a very short reply. 1. What is the ratio of the Unemployed females (as % of female labor force) in European Union in 1998 to that in 1999?
Your answer should be very brief. 1.04. What is the ratio of the Unemployed females (as % of female labor force) in Sub-Saharan Africa (developing only) in 1998 to that in 1999?
Offer a very short reply. 0.98. What is the ratio of the Unemployed females (as % of female labor force) of Rwanda in 1998 to that in 1999?
Your answer should be compact. 1. What is the difference between the highest and the second highest Unemployed females (as % of female labor force) of European Union?
Your response must be concise. 0.4. What is the difference between the highest and the second highest Unemployed females (as % of female labor force) of Sub-Saharan Africa (developing only)?
Provide a short and direct response. 0.26. What is the difference between the highest and the second highest Unemployed females (as % of female labor force) in Rwanda?
Make the answer very short. 0.1. What is the difference between the highest and the lowest Unemployed females (as % of female labor force) of European Union?
Give a very brief answer. 1.75. What is the difference between the highest and the lowest Unemployed females (as % of female labor force) of Sub-Saharan Africa (developing only)?
Your answer should be very brief. 0.94. 